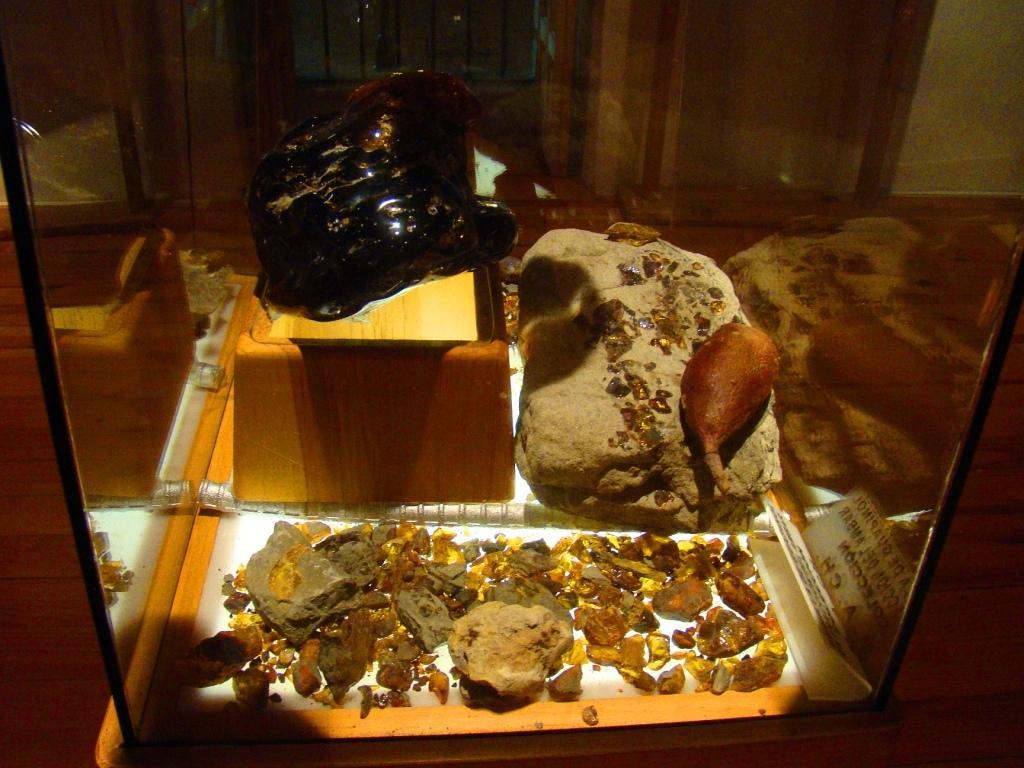Could you give a brief overview of what you see in this image? In this image I can see few stones in a glass table. 